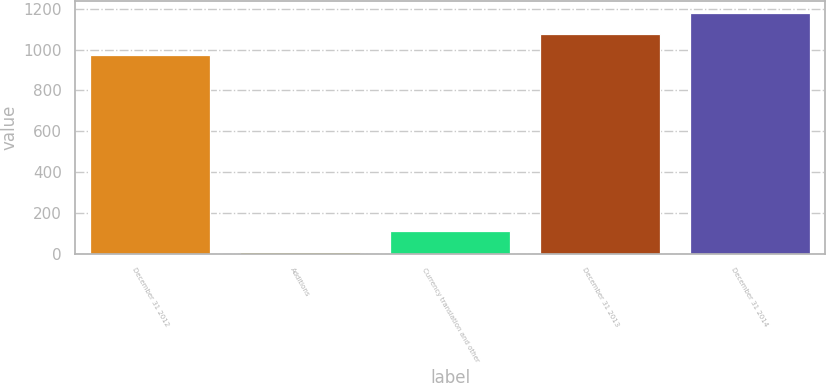Convert chart. <chart><loc_0><loc_0><loc_500><loc_500><bar_chart><fcel>December 31 2012<fcel>Additions<fcel>Currency translation and other<fcel>December 31 2013<fcel>December 31 2014<nl><fcel>975<fcel>7<fcel>109<fcel>1077<fcel>1179<nl></chart> 